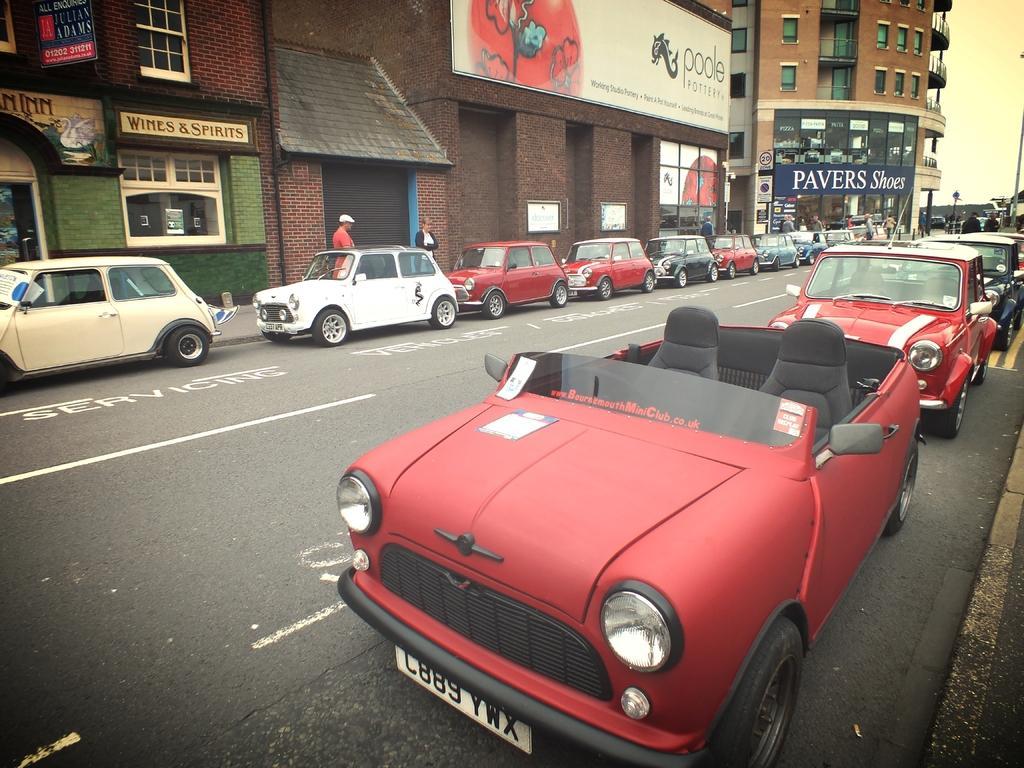Could you give a brief overview of what you see in this image? In this image there are cars on the road in the center and in the background there are buildings and there are boards with some text written on it and there are persons standing and walking. 